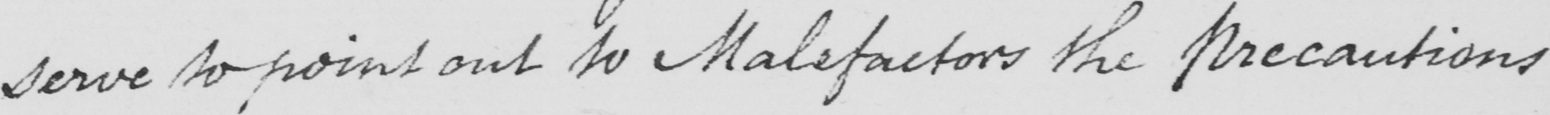Can you read and transcribe this handwriting? serve to point out to Malefactors the precautions 